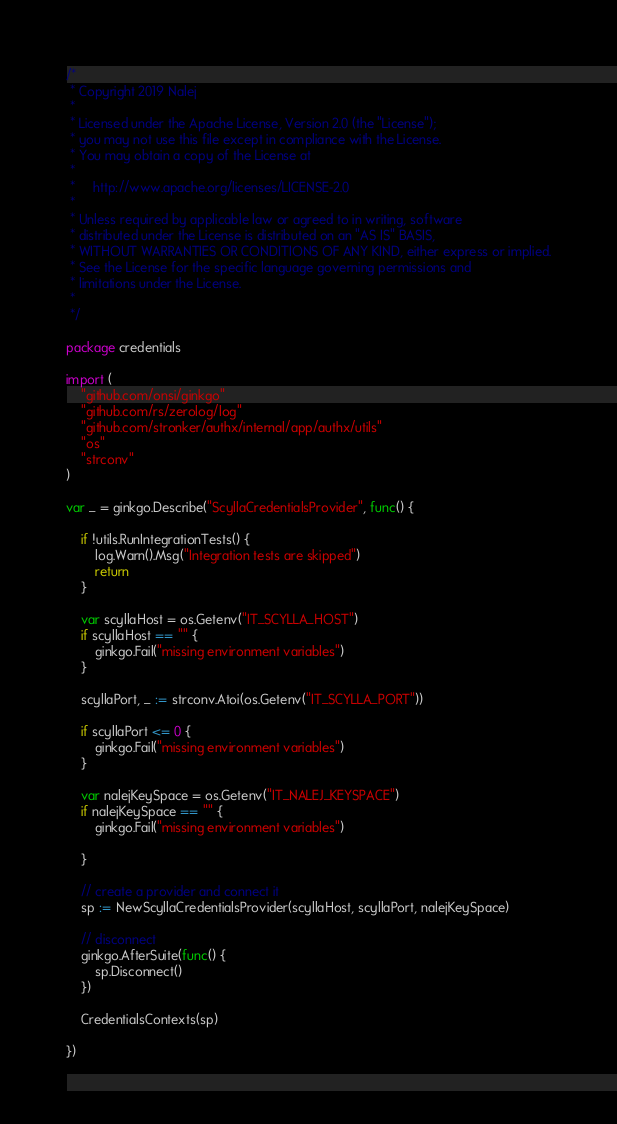<code> <loc_0><loc_0><loc_500><loc_500><_Go_>/*
 * Copyright 2019 Nalej
 *
 * Licensed under the Apache License, Version 2.0 (the "License");
 * you may not use this file except in compliance with the License.
 * You may obtain a copy of the License at
 *
 *     http://www.apache.org/licenses/LICENSE-2.0
 *
 * Unless required by applicable law or agreed to in writing, software
 * distributed under the License is distributed on an "AS IS" BASIS,
 * WITHOUT WARRANTIES OR CONDITIONS OF ANY KIND, either express or implied.
 * See the License for the specific language governing permissions and
 * limitations under the License.
 *
 */

package credentials

import (
	"github.com/onsi/ginkgo"
	"github.com/rs/zerolog/log"
	"github.com/stronker/authx/internal/app/authx/utils"
	"os"
	"strconv"
)

var _ = ginkgo.Describe("ScyllaCredentialsProvider", func() {
	
	if !utils.RunIntegrationTests() {
		log.Warn().Msg("Integration tests are skipped")
		return
	}
	
	var scyllaHost = os.Getenv("IT_SCYLLA_HOST")
	if scyllaHost == "" {
		ginkgo.Fail("missing environment variables")
	}
	
	scyllaPort, _ := strconv.Atoi(os.Getenv("IT_SCYLLA_PORT"))
	
	if scyllaPort <= 0 {
		ginkgo.Fail("missing environment variables")
	}
	
	var nalejKeySpace = os.Getenv("IT_NALEJ_KEYSPACE")
	if nalejKeySpace == "" {
		ginkgo.Fail("missing environment variables")
		
	}
	
	// create a provider and connect it
	sp := NewScyllaCredentialsProvider(scyllaHost, scyllaPort, nalejKeySpace)
	
	// disconnect
	ginkgo.AfterSuite(func() {
		sp.Disconnect()
	})
	
	CredentialsContexts(sp)
	
})
</code> 